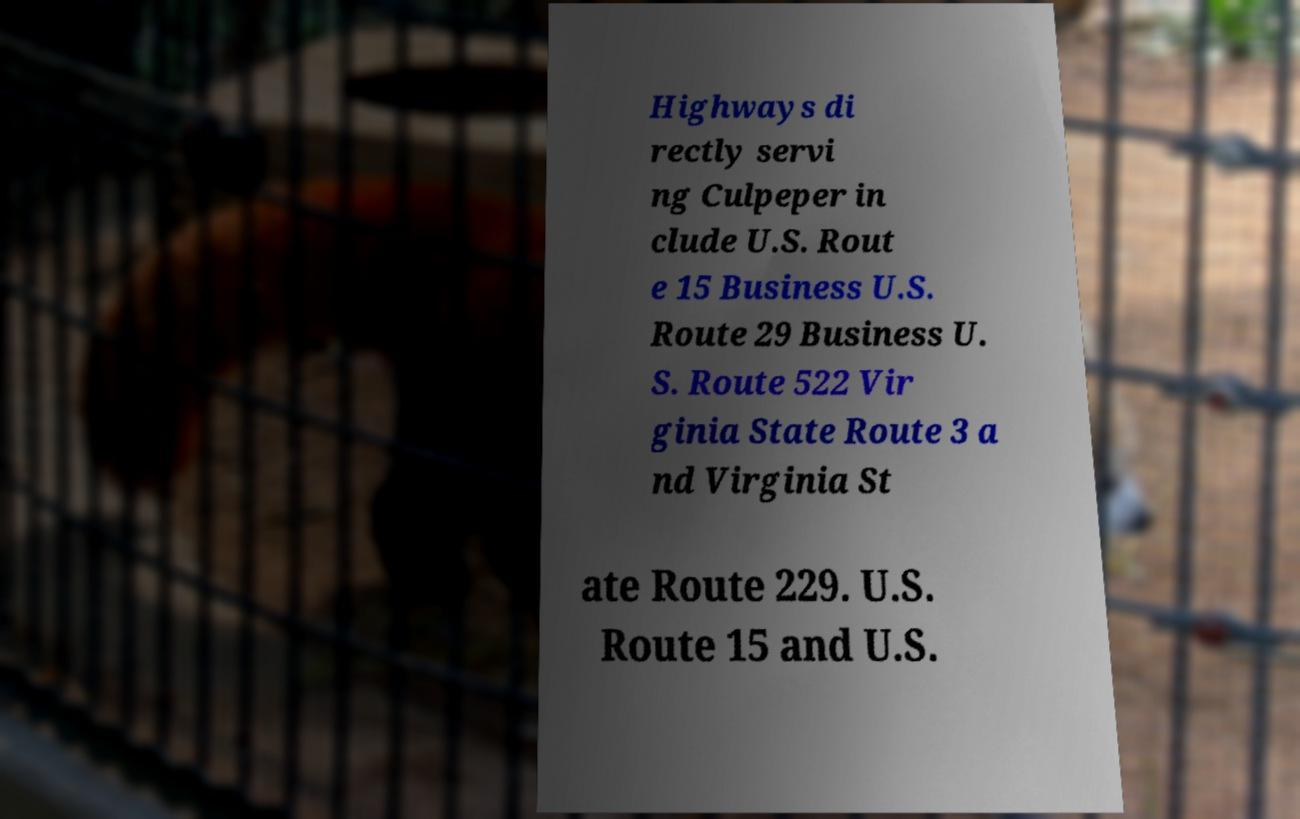Can you accurately transcribe the text from the provided image for me? Highways di rectly servi ng Culpeper in clude U.S. Rout e 15 Business U.S. Route 29 Business U. S. Route 522 Vir ginia State Route 3 a nd Virginia St ate Route 229. U.S. Route 15 and U.S. 